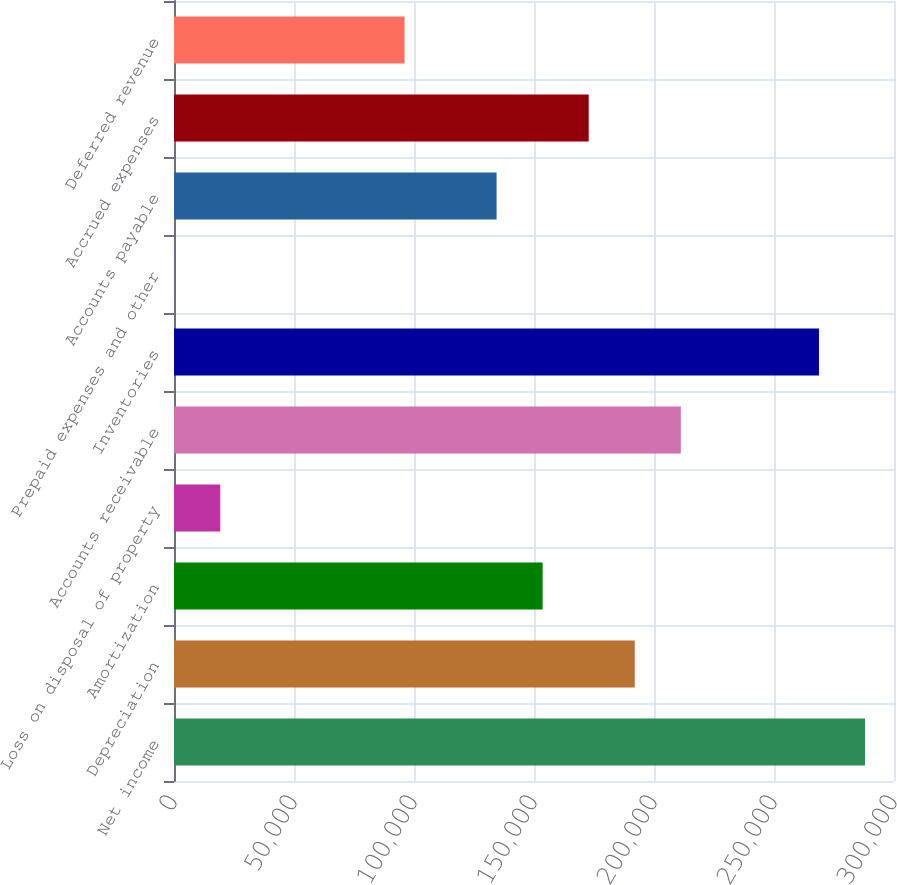<chart> <loc_0><loc_0><loc_500><loc_500><bar_chart><fcel>Net income<fcel>Depreciation<fcel>Amortization<fcel>Loss on disposal of property<fcel>Accounts receivable<fcel>Inventories<fcel>Prepaid expenses and other<fcel>Accounts payable<fcel>Accrued expenses<fcel>Deferred revenue<nl><fcel>287927<fcel>191982<fcel>153604<fcel>19281<fcel>211171<fcel>268738<fcel>92<fcel>134415<fcel>172793<fcel>96037<nl></chart> 